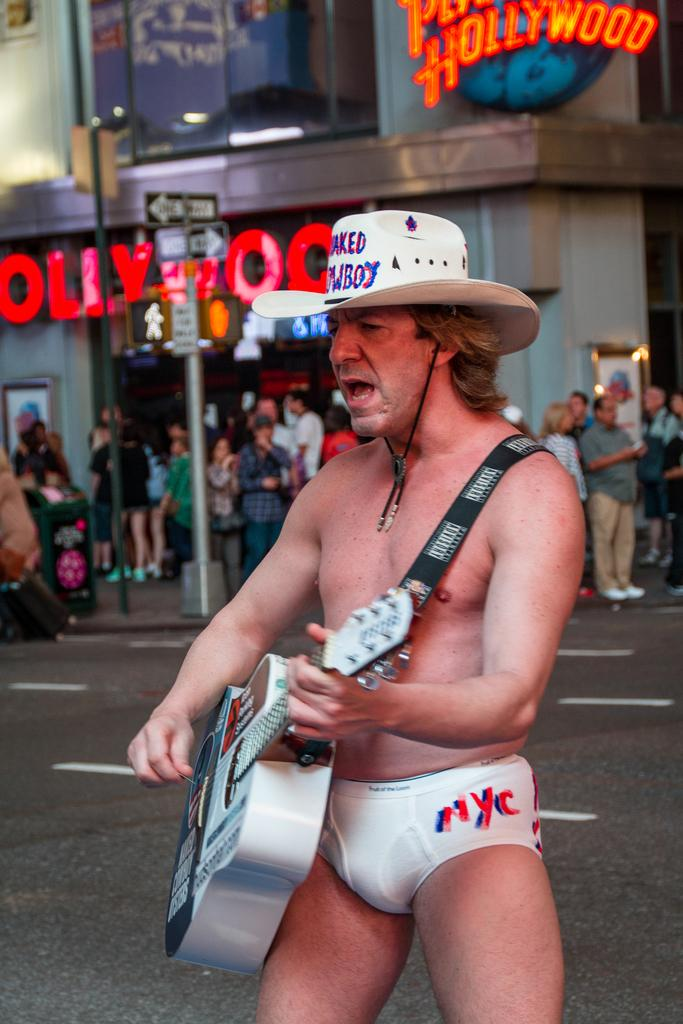What is the man in the image doing? The man is playing a guitar in the image. Can you describe the man's attire? The man is wearing a hat in the image. What can be seen in the background of the image? There are people, a board on a pole, a building, a hoarding, and a road in the background of the image. What type of whistle can be heard in the image? There is no whistle present in the image, and therefore no sound can be heard. What is the man wearing on his wrist in the image? The provided facts do not mention a watch or any wrist accessory, so it cannot be determined from the image. 